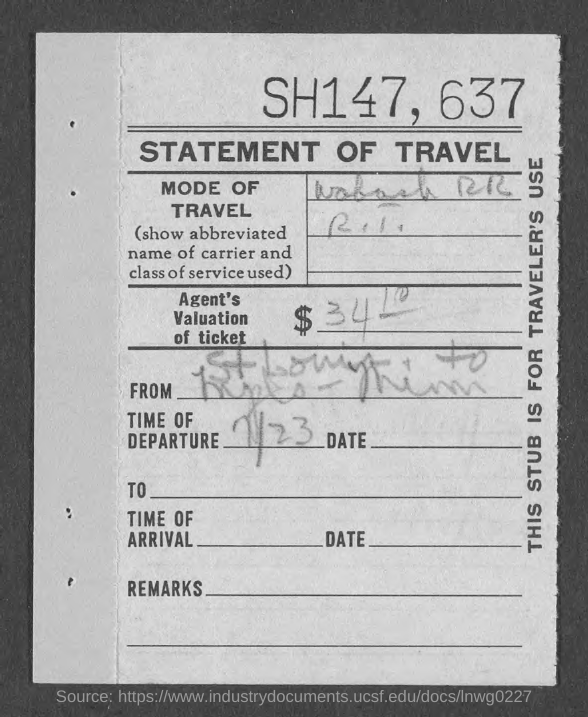What is the Title of the document?
Make the answer very short. STATEMENT OF TRAVEL. What is the time of departure?
Ensure brevity in your answer.  7/23. 